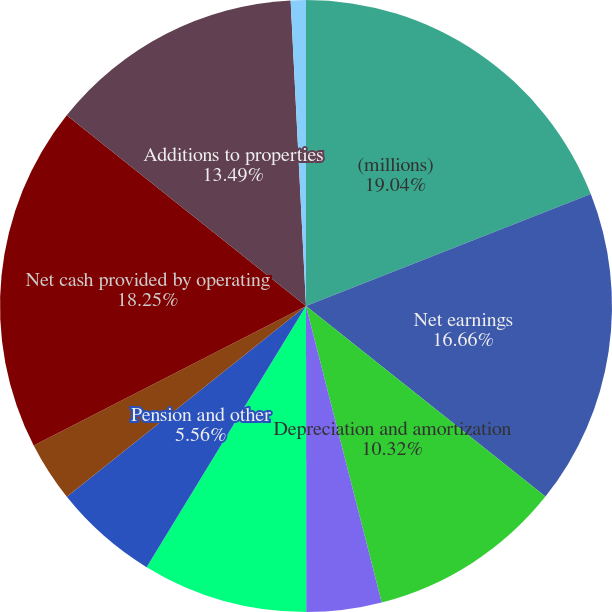<chart> <loc_0><loc_0><loc_500><loc_500><pie_chart><fcel>(millions)<fcel>Net earnings<fcel>Depreciation and amortization<fcel>Deferred income taxes<fcel>Other (a)<fcel>Pension and other<fcel>Changes in operating assets<fcel>Net cash provided by operating<fcel>Additions to properties<fcel>Property disposals<nl><fcel>19.04%<fcel>16.66%<fcel>10.32%<fcel>3.97%<fcel>8.73%<fcel>5.56%<fcel>3.18%<fcel>18.25%<fcel>13.49%<fcel>0.8%<nl></chart> 